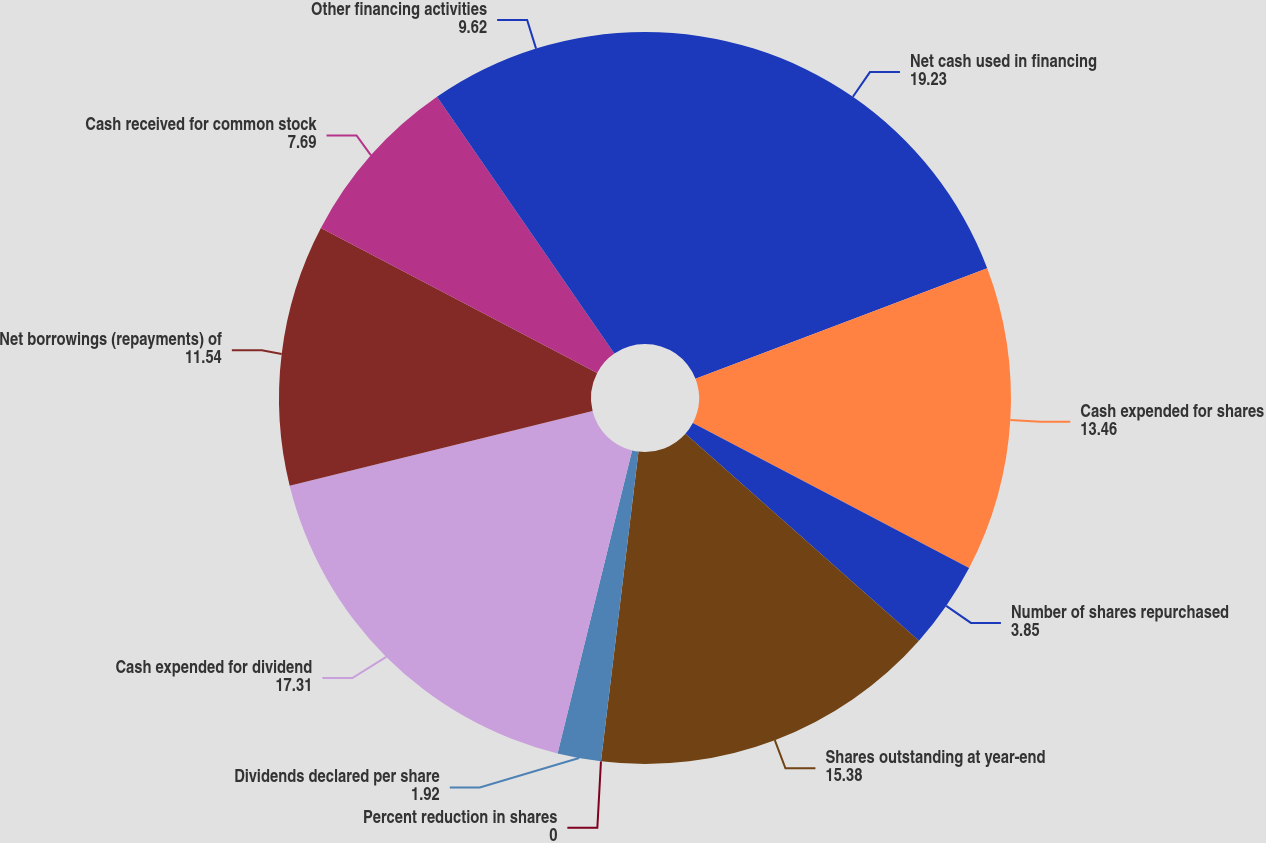Convert chart to OTSL. <chart><loc_0><loc_0><loc_500><loc_500><pie_chart><fcel>Net cash used in financing<fcel>Cash expended for shares<fcel>Number of shares repurchased<fcel>Shares outstanding at year-end<fcel>Percent reduction in shares<fcel>Dividends declared per share<fcel>Cash expended for dividend<fcel>Net borrowings (repayments) of<fcel>Cash received for common stock<fcel>Other financing activities<nl><fcel>19.23%<fcel>13.46%<fcel>3.85%<fcel>15.38%<fcel>0.0%<fcel>1.92%<fcel>17.31%<fcel>11.54%<fcel>7.69%<fcel>9.62%<nl></chart> 